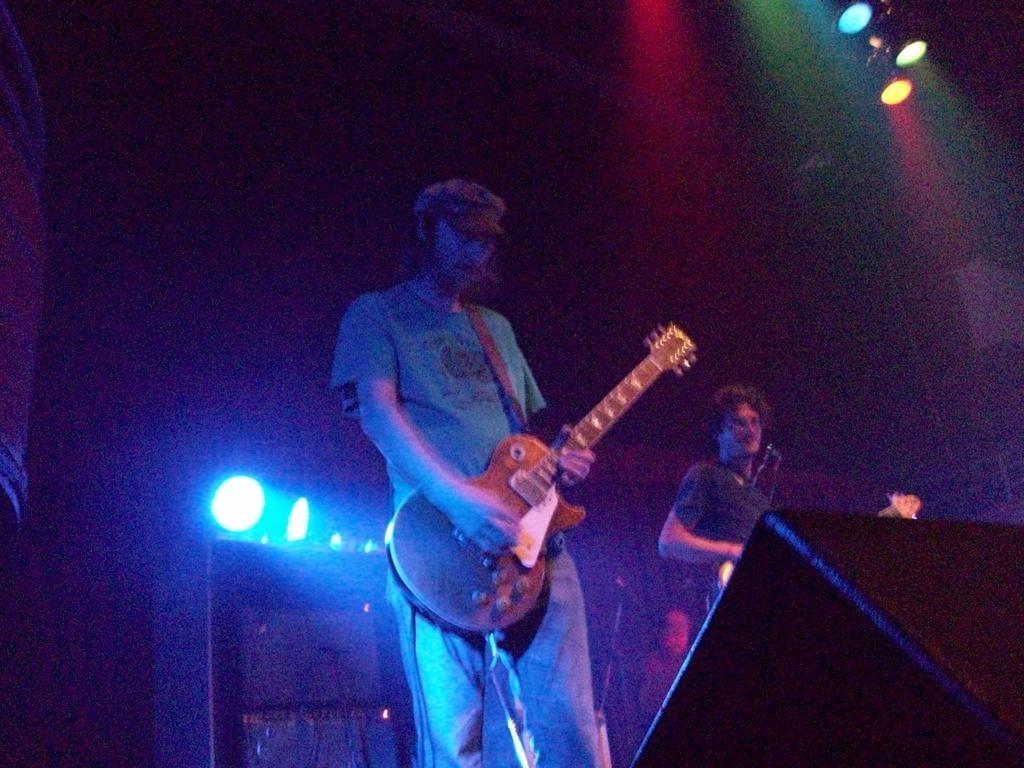How would you summarize this image in a sentence or two? There is a man standing on the floor holding a guitar in his hands. He's wearing a hat, cap on his head. Another guy is beside this man. In background we can observe some lights here. 